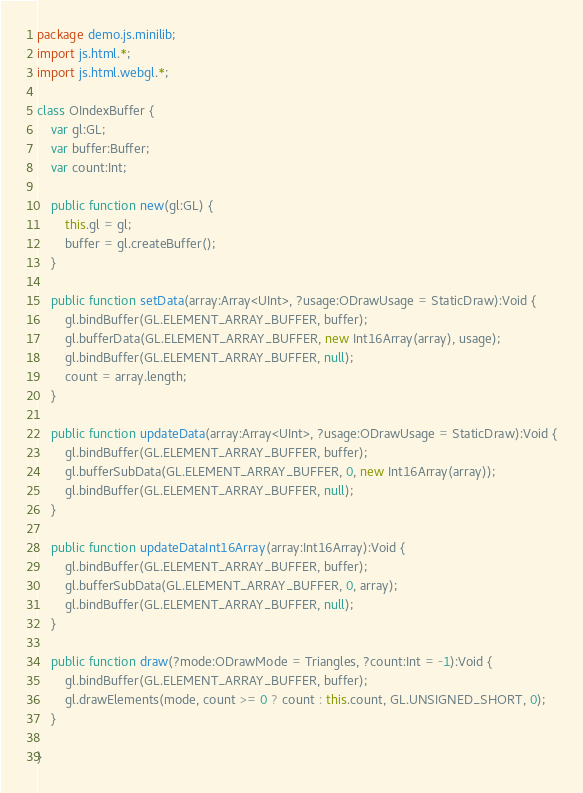<code> <loc_0><loc_0><loc_500><loc_500><_Haxe_>package demo.js.minilib;
import js.html.*;
import js.html.webgl.*;

class OIndexBuffer {
	var gl:GL;
	var buffer:Buffer;
	var count:Int;

	public function new(gl:GL) {
		this.gl = gl;
		buffer = gl.createBuffer();
	}

	public function setData(array:Array<UInt>, ?usage:ODrawUsage = StaticDraw):Void {
		gl.bindBuffer(GL.ELEMENT_ARRAY_BUFFER, buffer);
		gl.bufferData(GL.ELEMENT_ARRAY_BUFFER, new Int16Array(array), usage);
		gl.bindBuffer(GL.ELEMENT_ARRAY_BUFFER, null);
		count = array.length;
	}

	public function updateData(array:Array<UInt>, ?usage:ODrawUsage = StaticDraw):Void {
		gl.bindBuffer(GL.ELEMENT_ARRAY_BUFFER, buffer);
		gl.bufferSubData(GL.ELEMENT_ARRAY_BUFFER, 0, new Int16Array(array));
		gl.bindBuffer(GL.ELEMENT_ARRAY_BUFFER, null);
	}

	public function updateDataInt16Array(array:Int16Array):Void {
		gl.bindBuffer(GL.ELEMENT_ARRAY_BUFFER, buffer);
		gl.bufferSubData(GL.ELEMENT_ARRAY_BUFFER, 0, array);
		gl.bindBuffer(GL.ELEMENT_ARRAY_BUFFER, null);
	}

	public function draw(?mode:ODrawMode = Triangles, ?count:Int = -1):Void {
		gl.bindBuffer(GL.ELEMENT_ARRAY_BUFFER, buffer);
		gl.drawElements(mode, count >= 0 ? count : this.count, GL.UNSIGNED_SHORT, 0);
	}

}
</code> 